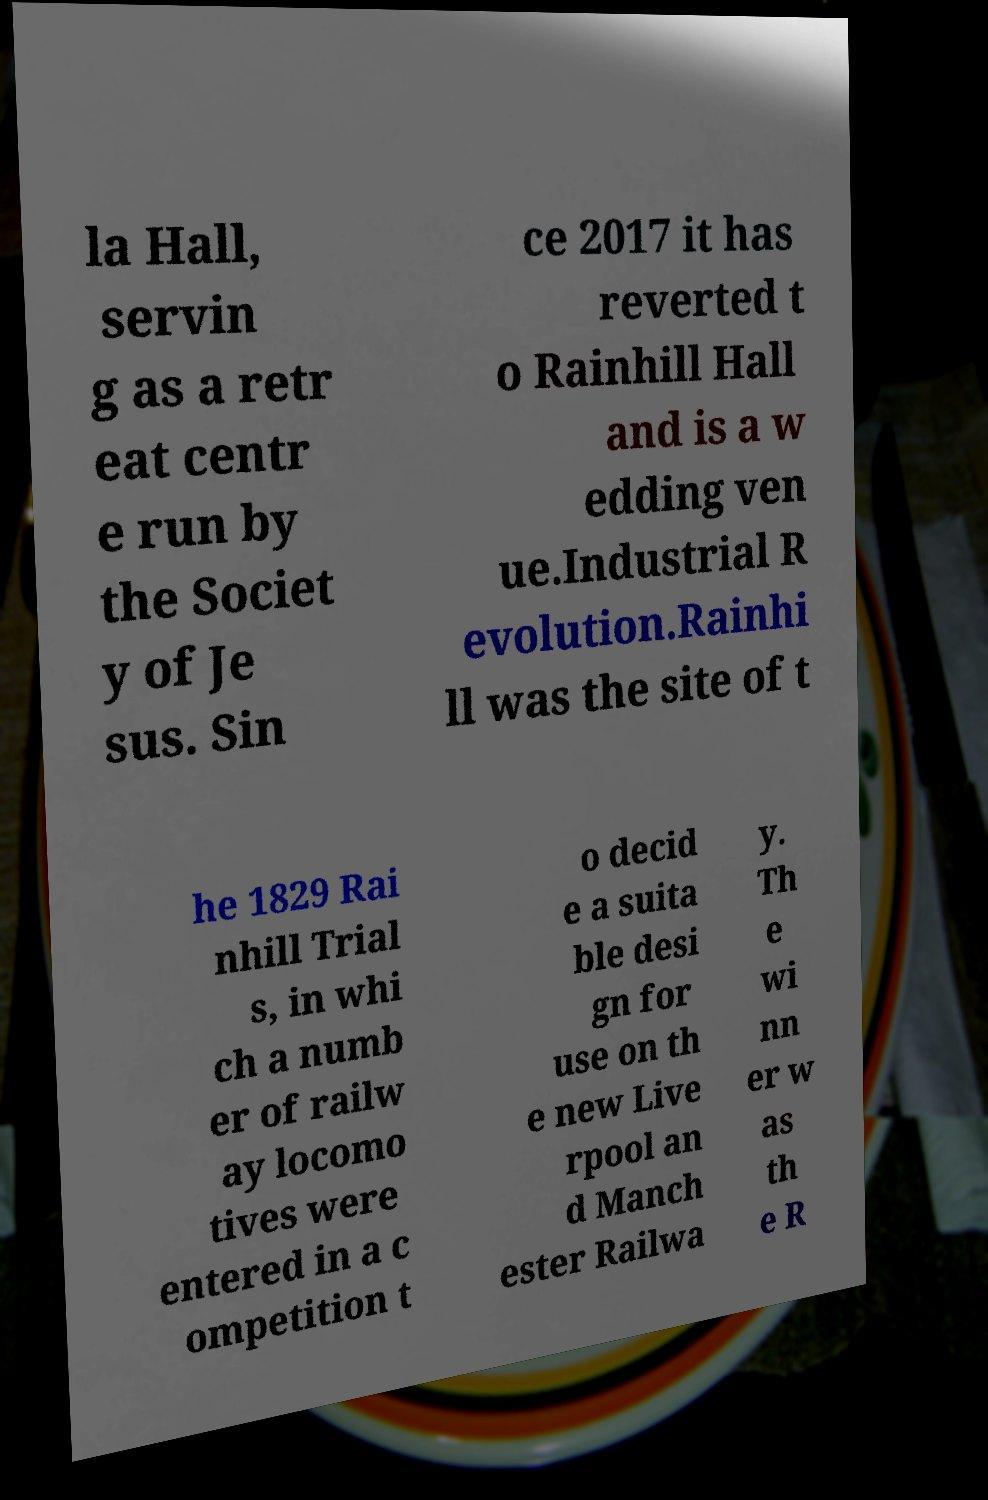Can you accurately transcribe the text from the provided image for me? la Hall, servin g as a retr eat centr e run by the Societ y of Je sus. Sin ce 2017 it has reverted t o Rainhill Hall and is a w edding ven ue.Industrial R evolution.Rainhi ll was the site of t he 1829 Rai nhill Trial s, in whi ch a numb er of railw ay locomo tives were entered in a c ompetition t o decid e a suita ble desi gn for use on th e new Live rpool an d Manch ester Railwa y. Th e wi nn er w as th e R 